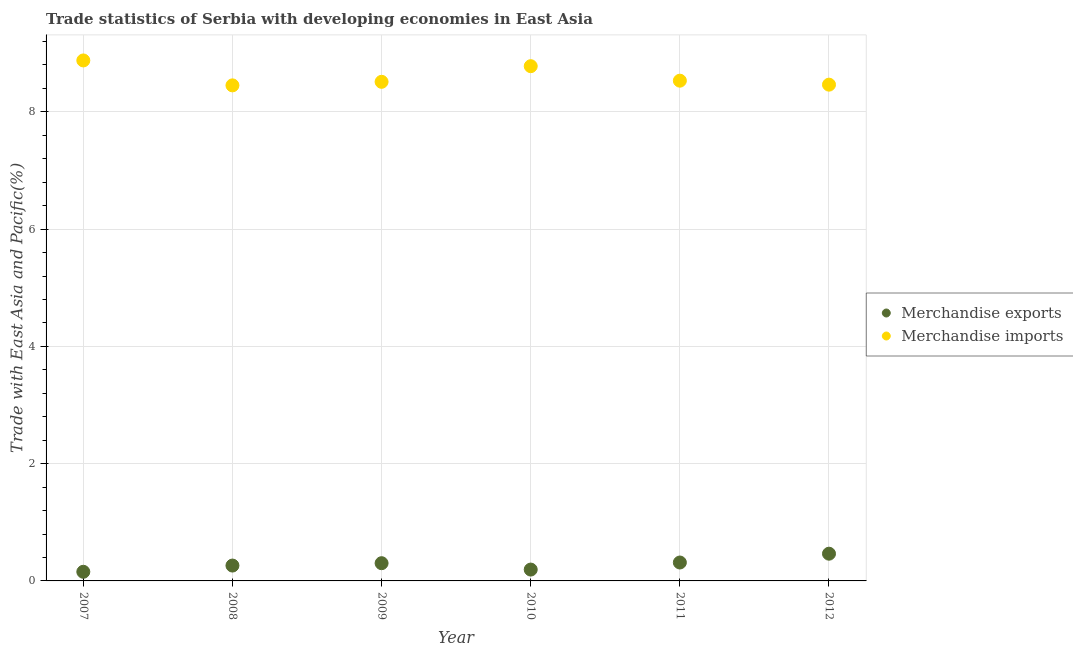What is the merchandise imports in 2007?
Offer a very short reply. 8.88. Across all years, what is the maximum merchandise imports?
Your response must be concise. 8.88. Across all years, what is the minimum merchandise imports?
Make the answer very short. 8.45. What is the total merchandise imports in the graph?
Your answer should be very brief. 51.61. What is the difference between the merchandise exports in 2007 and that in 2009?
Give a very brief answer. -0.15. What is the difference between the merchandise imports in 2010 and the merchandise exports in 2008?
Make the answer very short. 8.52. What is the average merchandise exports per year?
Keep it short and to the point. 0.28. In the year 2010, what is the difference between the merchandise exports and merchandise imports?
Provide a short and direct response. -8.59. What is the ratio of the merchandise imports in 2009 to that in 2012?
Offer a very short reply. 1.01. Is the difference between the merchandise exports in 2009 and 2010 greater than the difference between the merchandise imports in 2009 and 2010?
Provide a succinct answer. Yes. What is the difference between the highest and the second highest merchandise imports?
Make the answer very short. 0.1. What is the difference between the highest and the lowest merchandise exports?
Offer a terse response. 0.31. Does the merchandise exports monotonically increase over the years?
Your answer should be very brief. No. Is the merchandise imports strictly greater than the merchandise exports over the years?
Give a very brief answer. Yes. Is the merchandise exports strictly less than the merchandise imports over the years?
Your response must be concise. Yes. How many dotlines are there?
Your response must be concise. 2. How many years are there in the graph?
Your answer should be compact. 6. Does the graph contain any zero values?
Make the answer very short. No. Does the graph contain grids?
Provide a short and direct response. Yes. What is the title of the graph?
Keep it short and to the point. Trade statistics of Serbia with developing economies in East Asia. Does "Study and work" appear as one of the legend labels in the graph?
Your response must be concise. No. What is the label or title of the X-axis?
Your response must be concise. Year. What is the label or title of the Y-axis?
Ensure brevity in your answer.  Trade with East Asia and Pacific(%). What is the Trade with East Asia and Pacific(%) of Merchandise exports in 2007?
Give a very brief answer. 0.16. What is the Trade with East Asia and Pacific(%) of Merchandise imports in 2007?
Offer a very short reply. 8.88. What is the Trade with East Asia and Pacific(%) in Merchandise exports in 2008?
Your response must be concise. 0.26. What is the Trade with East Asia and Pacific(%) in Merchandise imports in 2008?
Your response must be concise. 8.45. What is the Trade with East Asia and Pacific(%) of Merchandise exports in 2009?
Keep it short and to the point. 0.3. What is the Trade with East Asia and Pacific(%) in Merchandise imports in 2009?
Offer a very short reply. 8.51. What is the Trade with East Asia and Pacific(%) of Merchandise exports in 2010?
Offer a terse response. 0.19. What is the Trade with East Asia and Pacific(%) in Merchandise imports in 2010?
Offer a terse response. 8.78. What is the Trade with East Asia and Pacific(%) of Merchandise exports in 2011?
Keep it short and to the point. 0.31. What is the Trade with East Asia and Pacific(%) in Merchandise imports in 2011?
Ensure brevity in your answer.  8.53. What is the Trade with East Asia and Pacific(%) of Merchandise exports in 2012?
Your answer should be very brief. 0.46. What is the Trade with East Asia and Pacific(%) of Merchandise imports in 2012?
Offer a very short reply. 8.46. Across all years, what is the maximum Trade with East Asia and Pacific(%) of Merchandise exports?
Ensure brevity in your answer.  0.46. Across all years, what is the maximum Trade with East Asia and Pacific(%) of Merchandise imports?
Give a very brief answer. 8.88. Across all years, what is the minimum Trade with East Asia and Pacific(%) in Merchandise exports?
Give a very brief answer. 0.16. Across all years, what is the minimum Trade with East Asia and Pacific(%) of Merchandise imports?
Offer a very short reply. 8.45. What is the total Trade with East Asia and Pacific(%) of Merchandise exports in the graph?
Offer a terse response. 1.69. What is the total Trade with East Asia and Pacific(%) of Merchandise imports in the graph?
Provide a succinct answer. 51.61. What is the difference between the Trade with East Asia and Pacific(%) in Merchandise exports in 2007 and that in 2008?
Keep it short and to the point. -0.11. What is the difference between the Trade with East Asia and Pacific(%) of Merchandise imports in 2007 and that in 2008?
Ensure brevity in your answer.  0.43. What is the difference between the Trade with East Asia and Pacific(%) in Merchandise exports in 2007 and that in 2009?
Your answer should be compact. -0.15. What is the difference between the Trade with East Asia and Pacific(%) in Merchandise imports in 2007 and that in 2009?
Offer a terse response. 0.36. What is the difference between the Trade with East Asia and Pacific(%) of Merchandise exports in 2007 and that in 2010?
Provide a short and direct response. -0.04. What is the difference between the Trade with East Asia and Pacific(%) in Merchandise imports in 2007 and that in 2010?
Your answer should be compact. 0.1. What is the difference between the Trade with East Asia and Pacific(%) of Merchandise exports in 2007 and that in 2011?
Ensure brevity in your answer.  -0.16. What is the difference between the Trade with East Asia and Pacific(%) of Merchandise imports in 2007 and that in 2011?
Ensure brevity in your answer.  0.35. What is the difference between the Trade with East Asia and Pacific(%) of Merchandise exports in 2007 and that in 2012?
Provide a succinct answer. -0.31. What is the difference between the Trade with East Asia and Pacific(%) of Merchandise imports in 2007 and that in 2012?
Keep it short and to the point. 0.41. What is the difference between the Trade with East Asia and Pacific(%) in Merchandise exports in 2008 and that in 2009?
Make the answer very short. -0.04. What is the difference between the Trade with East Asia and Pacific(%) in Merchandise imports in 2008 and that in 2009?
Keep it short and to the point. -0.06. What is the difference between the Trade with East Asia and Pacific(%) of Merchandise exports in 2008 and that in 2010?
Provide a succinct answer. 0.07. What is the difference between the Trade with East Asia and Pacific(%) in Merchandise imports in 2008 and that in 2010?
Your answer should be compact. -0.33. What is the difference between the Trade with East Asia and Pacific(%) of Merchandise exports in 2008 and that in 2011?
Keep it short and to the point. -0.05. What is the difference between the Trade with East Asia and Pacific(%) of Merchandise imports in 2008 and that in 2011?
Keep it short and to the point. -0.08. What is the difference between the Trade with East Asia and Pacific(%) of Merchandise exports in 2008 and that in 2012?
Ensure brevity in your answer.  -0.2. What is the difference between the Trade with East Asia and Pacific(%) of Merchandise imports in 2008 and that in 2012?
Provide a succinct answer. -0.01. What is the difference between the Trade with East Asia and Pacific(%) in Merchandise exports in 2009 and that in 2010?
Keep it short and to the point. 0.11. What is the difference between the Trade with East Asia and Pacific(%) of Merchandise imports in 2009 and that in 2010?
Give a very brief answer. -0.27. What is the difference between the Trade with East Asia and Pacific(%) of Merchandise exports in 2009 and that in 2011?
Keep it short and to the point. -0.01. What is the difference between the Trade with East Asia and Pacific(%) in Merchandise imports in 2009 and that in 2011?
Keep it short and to the point. -0.02. What is the difference between the Trade with East Asia and Pacific(%) in Merchandise exports in 2009 and that in 2012?
Offer a terse response. -0.16. What is the difference between the Trade with East Asia and Pacific(%) of Merchandise imports in 2009 and that in 2012?
Your answer should be very brief. 0.05. What is the difference between the Trade with East Asia and Pacific(%) in Merchandise exports in 2010 and that in 2011?
Your answer should be very brief. -0.12. What is the difference between the Trade with East Asia and Pacific(%) in Merchandise imports in 2010 and that in 2011?
Provide a succinct answer. 0.25. What is the difference between the Trade with East Asia and Pacific(%) of Merchandise exports in 2010 and that in 2012?
Offer a very short reply. -0.27. What is the difference between the Trade with East Asia and Pacific(%) in Merchandise imports in 2010 and that in 2012?
Your response must be concise. 0.32. What is the difference between the Trade with East Asia and Pacific(%) of Merchandise exports in 2011 and that in 2012?
Your answer should be very brief. -0.15. What is the difference between the Trade with East Asia and Pacific(%) of Merchandise imports in 2011 and that in 2012?
Your response must be concise. 0.07. What is the difference between the Trade with East Asia and Pacific(%) of Merchandise exports in 2007 and the Trade with East Asia and Pacific(%) of Merchandise imports in 2008?
Provide a succinct answer. -8.3. What is the difference between the Trade with East Asia and Pacific(%) of Merchandise exports in 2007 and the Trade with East Asia and Pacific(%) of Merchandise imports in 2009?
Your response must be concise. -8.36. What is the difference between the Trade with East Asia and Pacific(%) of Merchandise exports in 2007 and the Trade with East Asia and Pacific(%) of Merchandise imports in 2010?
Offer a terse response. -8.62. What is the difference between the Trade with East Asia and Pacific(%) of Merchandise exports in 2007 and the Trade with East Asia and Pacific(%) of Merchandise imports in 2011?
Ensure brevity in your answer.  -8.38. What is the difference between the Trade with East Asia and Pacific(%) in Merchandise exports in 2007 and the Trade with East Asia and Pacific(%) in Merchandise imports in 2012?
Provide a succinct answer. -8.31. What is the difference between the Trade with East Asia and Pacific(%) of Merchandise exports in 2008 and the Trade with East Asia and Pacific(%) of Merchandise imports in 2009?
Offer a terse response. -8.25. What is the difference between the Trade with East Asia and Pacific(%) of Merchandise exports in 2008 and the Trade with East Asia and Pacific(%) of Merchandise imports in 2010?
Make the answer very short. -8.52. What is the difference between the Trade with East Asia and Pacific(%) of Merchandise exports in 2008 and the Trade with East Asia and Pacific(%) of Merchandise imports in 2011?
Your answer should be very brief. -8.27. What is the difference between the Trade with East Asia and Pacific(%) in Merchandise exports in 2008 and the Trade with East Asia and Pacific(%) in Merchandise imports in 2012?
Offer a terse response. -8.2. What is the difference between the Trade with East Asia and Pacific(%) in Merchandise exports in 2009 and the Trade with East Asia and Pacific(%) in Merchandise imports in 2010?
Offer a very short reply. -8.48. What is the difference between the Trade with East Asia and Pacific(%) of Merchandise exports in 2009 and the Trade with East Asia and Pacific(%) of Merchandise imports in 2011?
Make the answer very short. -8.23. What is the difference between the Trade with East Asia and Pacific(%) in Merchandise exports in 2009 and the Trade with East Asia and Pacific(%) in Merchandise imports in 2012?
Your response must be concise. -8.16. What is the difference between the Trade with East Asia and Pacific(%) of Merchandise exports in 2010 and the Trade with East Asia and Pacific(%) of Merchandise imports in 2011?
Your response must be concise. -8.34. What is the difference between the Trade with East Asia and Pacific(%) in Merchandise exports in 2010 and the Trade with East Asia and Pacific(%) in Merchandise imports in 2012?
Keep it short and to the point. -8.27. What is the difference between the Trade with East Asia and Pacific(%) of Merchandise exports in 2011 and the Trade with East Asia and Pacific(%) of Merchandise imports in 2012?
Your response must be concise. -8.15. What is the average Trade with East Asia and Pacific(%) of Merchandise exports per year?
Provide a succinct answer. 0.28. What is the average Trade with East Asia and Pacific(%) of Merchandise imports per year?
Keep it short and to the point. 8.6. In the year 2007, what is the difference between the Trade with East Asia and Pacific(%) in Merchandise exports and Trade with East Asia and Pacific(%) in Merchandise imports?
Give a very brief answer. -8.72. In the year 2008, what is the difference between the Trade with East Asia and Pacific(%) of Merchandise exports and Trade with East Asia and Pacific(%) of Merchandise imports?
Ensure brevity in your answer.  -8.19. In the year 2009, what is the difference between the Trade with East Asia and Pacific(%) of Merchandise exports and Trade with East Asia and Pacific(%) of Merchandise imports?
Ensure brevity in your answer.  -8.21. In the year 2010, what is the difference between the Trade with East Asia and Pacific(%) in Merchandise exports and Trade with East Asia and Pacific(%) in Merchandise imports?
Your answer should be very brief. -8.59. In the year 2011, what is the difference between the Trade with East Asia and Pacific(%) of Merchandise exports and Trade with East Asia and Pacific(%) of Merchandise imports?
Your response must be concise. -8.22. In the year 2012, what is the difference between the Trade with East Asia and Pacific(%) in Merchandise exports and Trade with East Asia and Pacific(%) in Merchandise imports?
Your response must be concise. -8. What is the ratio of the Trade with East Asia and Pacific(%) in Merchandise exports in 2007 to that in 2008?
Your answer should be compact. 0.59. What is the ratio of the Trade with East Asia and Pacific(%) in Merchandise imports in 2007 to that in 2008?
Your response must be concise. 1.05. What is the ratio of the Trade with East Asia and Pacific(%) of Merchandise exports in 2007 to that in 2009?
Provide a succinct answer. 0.52. What is the ratio of the Trade with East Asia and Pacific(%) in Merchandise imports in 2007 to that in 2009?
Keep it short and to the point. 1.04. What is the ratio of the Trade with East Asia and Pacific(%) in Merchandise exports in 2007 to that in 2010?
Offer a terse response. 0.8. What is the ratio of the Trade with East Asia and Pacific(%) in Merchandise imports in 2007 to that in 2010?
Make the answer very short. 1.01. What is the ratio of the Trade with East Asia and Pacific(%) of Merchandise exports in 2007 to that in 2011?
Your response must be concise. 0.5. What is the ratio of the Trade with East Asia and Pacific(%) in Merchandise imports in 2007 to that in 2011?
Ensure brevity in your answer.  1.04. What is the ratio of the Trade with East Asia and Pacific(%) in Merchandise exports in 2007 to that in 2012?
Keep it short and to the point. 0.34. What is the ratio of the Trade with East Asia and Pacific(%) of Merchandise imports in 2007 to that in 2012?
Keep it short and to the point. 1.05. What is the ratio of the Trade with East Asia and Pacific(%) of Merchandise exports in 2008 to that in 2009?
Offer a very short reply. 0.87. What is the ratio of the Trade with East Asia and Pacific(%) of Merchandise exports in 2008 to that in 2010?
Your answer should be very brief. 1.35. What is the ratio of the Trade with East Asia and Pacific(%) in Merchandise imports in 2008 to that in 2010?
Make the answer very short. 0.96. What is the ratio of the Trade with East Asia and Pacific(%) in Merchandise exports in 2008 to that in 2011?
Your response must be concise. 0.83. What is the ratio of the Trade with East Asia and Pacific(%) in Merchandise imports in 2008 to that in 2011?
Your answer should be very brief. 0.99. What is the ratio of the Trade with East Asia and Pacific(%) of Merchandise exports in 2008 to that in 2012?
Offer a very short reply. 0.56. What is the ratio of the Trade with East Asia and Pacific(%) in Merchandise exports in 2009 to that in 2010?
Offer a very short reply. 1.56. What is the ratio of the Trade with East Asia and Pacific(%) of Merchandise imports in 2009 to that in 2010?
Your response must be concise. 0.97. What is the ratio of the Trade with East Asia and Pacific(%) in Merchandise exports in 2009 to that in 2011?
Make the answer very short. 0.96. What is the ratio of the Trade with East Asia and Pacific(%) in Merchandise imports in 2009 to that in 2011?
Your response must be concise. 1. What is the ratio of the Trade with East Asia and Pacific(%) of Merchandise exports in 2009 to that in 2012?
Provide a succinct answer. 0.65. What is the ratio of the Trade with East Asia and Pacific(%) in Merchandise imports in 2009 to that in 2012?
Provide a succinct answer. 1.01. What is the ratio of the Trade with East Asia and Pacific(%) in Merchandise exports in 2010 to that in 2011?
Offer a terse response. 0.62. What is the ratio of the Trade with East Asia and Pacific(%) in Merchandise exports in 2010 to that in 2012?
Offer a very short reply. 0.42. What is the ratio of the Trade with East Asia and Pacific(%) in Merchandise imports in 2010 to that in 2012?
Provide a short and direct response. 1.04. What is the ratio of the Trade with East Asia and Pacific(%) in Merchandise exports in 2011 to that in 2012?
Your response must be concise. 0.68. What is the difference between the highest and the second highest Trade with East Asia and Pacific(%) of Merchandise exports?
Make the answer very short. 0.15. What is the difference between the highest and the second highest Trade with East Asia and Pacific(%) of Merchandise imports?
Offer a very short reply. 0.1. What is the difference between the highest and the lowest Trade with East Asia and Pacific(%) of Merchandise exports?
Offer a terse response. 0.31. What is the difference between the highest and the lowest Trade with East Asia and Pacific(%) in Merchandise imports?
Provide a succinct answer. 0.43. 